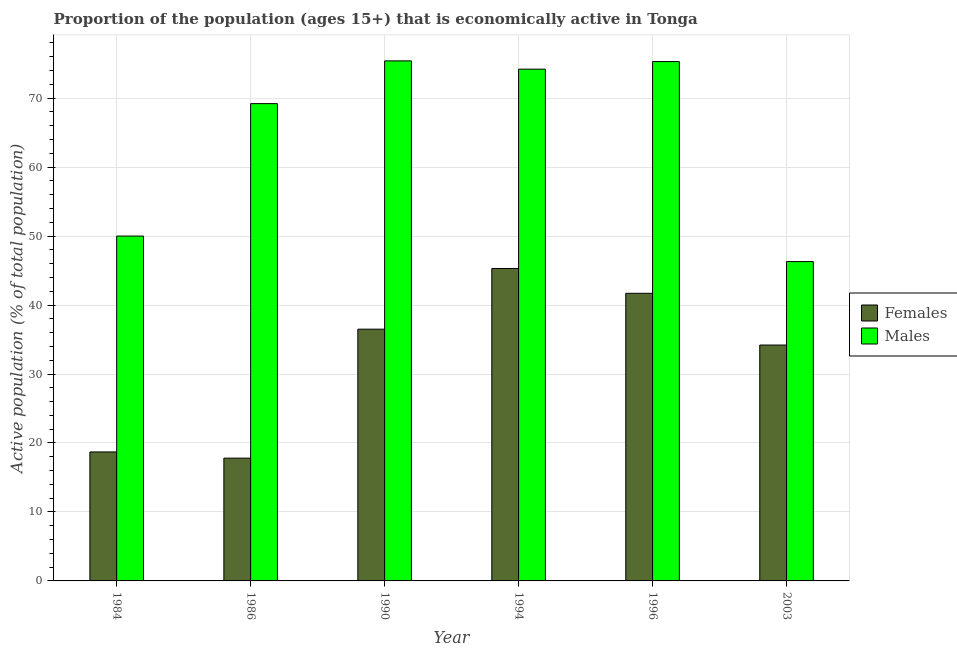How many groups of bars are there?
Ensure brevity in your answer.  6. Are the number of bars per tick equal to the number of legend labels?
Provide a succinct answer. Yes. Are the number of bars on each tick of the X-axis equal?
Your answer should be very brief. Yes. How many bars are there on the 4th tick from the left?
Provide a succinct answer. 2. In how many cases, is the number of bars for a given year not equal to the number of legend labels?
Offer a very short reply. 0. What is the percentage of economically active female population in 1990?
Make the answer very short. 36.5. Across all years, what is the maximum percentage of economically active female population?
Offer a very short reply. 45.3. Across all years, what is the minimum percentage of economically active male population?
Offer a terse response. 46.3. In which year was the percentage of economically active male population maximum?
Give a very brief answer. 1990. What is the total percentage of economically active female population in the graph?
Make the answer very short. 194.2. What is the difference between the percentage of economically active female population in 1990 and that in 1994?
Ensure brevity in your answer.  -8.8. What is the difference between the percentage of economically active male population in 1994 and the percentage of economically active female population in 1990?
Ensure brevity in your answer.  -1.2. What is the average percentage of economically active female population per year?
Your response must be concise. 32.37. In the year 2003, what is the difference between the percentage of economically active male population and percentage of economically active female population?
Provide a short and direct response. 0. In how many years, is the percentage of economically active female population greater than 50 %?
Keep it short and to the point. 0. What is the ratio of the percentage of economically active male population in 1984 to that in 1996?
Your response must be concise. 0.66. Is the percentage of economically active male population in 1990 less than that in 1994?
Make the answer very short. No. What is the difference between the highest and the second highest percentage of economically active male population?
Your answer should be very brief. 0.1. What is the difference between the highest and the lowest percentage of economically active female population?
Give a very brief answer. 27.5. Is the sum of the percentage of economically active male population in 1990 and 2003 greater than the maximum percentage of economically active female population across all years?
Keep it short and to the point. Yes. What does the 1st bar from the left in 1990 represents?
Give a very brief answer. Females. What does the 1st bar from the right in 2003 represents?
Your response must be concise. Males. How many bars are there?
Keep it short and to the point. 12. Are all the bars in the graph horizontal?
Offer a terse response. No. What is the difference between two consecutive major ticks on the Y-axis?
Offer a terse response. 10. Are the values on the major ticks of Y-axis written in scientific E-notation?
Your answer should be compact. No. Does the graph contain any zero values?
Your answer should be compact. No. How are the legend labels stacked?
Provide a succinct answer. Vertical. What is the title of the graph?
Keep it short and to the point. Proportion of the population (ages 15+) that is economically active in Tonga. Does "Methane emissions" appear as one of the legend labels in the graph?
Give a very brief answer. No. What is the label or title of the X-axis?
Give a very brief answer. Year. What is the label or title of the Y-axis?
Your answer should be very brief. Active population (% of total population). What is the Active population (% of total population) of Females in 1984?
Your answer should be very brief. 18.7. What is the Active population (% of total population) of Males in 1984?
Your answer should be very brief. 50. What is the Active population (% of total population) of Females in 1986?
Your response must be concise. 17.8. What is the Active population (% of total population) of Males in 1986?
Provide a short and direct response. 69.2. What is the Active population (% of total population) of Females in 1990?
Your answer should be very brief. 36.5. What is the Active population (% of total population) of Males in 1990?
Provide a short and direct response. 75.4. What is the Active population (% of total population) in Females in 1994?
Provide a short and direct response. 45.3. What is the Active population (% of total population) in Males in 1994?
Offer a very short reply. 74.2. What is the Active population (% of total population) in Females in 1996?
Make the answer very short. 41.7. What is the Active population (% of total population) in Males in 1996?
Offer a very short reply. 75.3. What is the Active population (% of total population) in Females in 2003?
Offer a terse response. 34.2. What is the Active population (% of total population) of Males in 2003?
Your response must be concise. 46.3. Across all years, what is the maximum Active population (% of total population) in Females?
Your answer should be compact. 45.3. Across all years, what is the maximum Active population (% of total population) of Males?
Keep it short and to the point. 75.4. Across all years, what is the minimum Active population (% of total population) of Females?
Your answer should be compact. 17.8. Across all years, what is the minimum Active population (% of total population) in Males?
Provide a succinct answer. 46.3. What is the total Active population (% of total population) of Females in the graph?
Your response must be concise. 194.2. What is the total Active population (% of total population) in Males in the graph?
Give a very brief answer. 390.4. What is the difference between the Active population (% of total population) in Males in 1984 and that in 1986?
Provide a succinct answer. -19.2. What is the difference between the Active population (% of total population) in Females in 1984 and that in 1990?
Your response must be concise. -17.8. What is the difference between the Active population (% of total population) in Males in 1984 and that in 1990?
Provide a succinct answer. -25.4. What is the difference between the Active population (% of total population) of Females in 1984 and that in 1994?
Offer a terse response. -26.6. What is the difference between the Active population (% of total population) in Males in 1984 and that in 1994?
Keep it short and to the point. -24.2. What is the difference between the Active population (% of total population) of Males in 1984 and that in 1996?
Provide a succinct answer. -25.3. What is the difference between the Active population (% of total population) of Females in 1984 and that in 2003?
Make the answer very short. -15.5. What is the difference between the Active population (% of total population) of Males in 1984 and that in 2003?
Give a very brief answer. 3.7. What is the difference between the Active population (% of total population) in Females in 1986 and that in 1990?
Your answer should be very brief. -18.7. What is the difference between the Active population (% of total population) in Females in 1986 and that in 1994?
Your response must be concise. -27.5. What is the difference between the Active population (% of total population) in Males in 1986 and that in 1994?
Your response must be concise. -5. What is the difference between the Active population (% of total population) of Females in 1986 and that in 1996?
Provide a short and direct response. -23.9. What is the difference between the Active population (% of total population) in Females in 1986 and that in 2003?
Keep it short and to the point. -16.4. What is the difference between the Active population (% of total population) in Males in 1986 and that in 2003?
Ensure brevity in your answer.  22.9. What is the difference between the Active population (% of total population) of Males in 1990 and that in 1994?
Make the answer very short. 1.2. What is the difference between the Active population (% of total population) of Females in 1990 and that in 1996?
Ensure brevity in your answer.  -5.2. What is the difference between the Active population (% of total population) of Males in 1990 and that in 2003?
Offer a very short reply. 29.1. What is the difference between the Active population (% of total population) of Males in 1994 and that in 1996?
Your response must be concise. -1.1. What is the difference between the Active population (% of total population) in Females in 1994 and that in 2003?
Offer a terse response. 11.1. What is the difference between the Active population (% of total population) in Males in 1994 and that in 2003?
Provide a succinct answer. 27.9. What is the difference between the Active population (% of total population) of Males in 1996 and that in 2003?
Keep it short and to the point. 29. What is the difference between the Active population (% of total population) of Females in 1984 and the Active population (% of total population) of Males in 1986?
Give a very brief answer. -50.5. What is the difference between the Active population (% of total population) in Females in 1984 and the Active population (% of total population) in Males in 1990?
Give a very brief answer. -56.7. What is the difference between the Active population (% of total population) in Females in 1984 and the Active population (% of total population) in Males in 1994?
Keep it short and to the point. -55.5. What is the difference between the Active population (% of total population) in Females in 1984 and the Active population (% of total population) in Males in 1996?
Provide a short and direct response. -56.6. What is the difference between the Active population (% of total population) of Females in 1984 and the Active population (% of total population) of Males in 2003?
Your answer should be very brief. -27.6. What is the difference between the Active population (% of total population) in Females in 1986 and the Active population (% of total population) in Males in 1990?
Offer a terse response. -57.6. What is the difference between the Active population (% of total population) of Females in 1986 and the Active population (% of total population) of Males in 1994?
Provide a short and direct response. -56.4. What is the difference between the Active population (% of total population) in Females in 1986 and the Active population (% of total population) in Males in 1996?
Offer a very short reply. -57.5. What is the difference between the Active population (% of total population) in Females in 1986 and the Active population (% of total population) in Males in 2003?
Ensure brevity in your answer.  -28.5. What is the difference between the Active population (% of total population) in Females in 1990 and the Active population (% of total population) in Males in 1994?
Your answer should be compact. -37.7. What is the difference between the Active population (% of total population) in Females in 1990 and the Active population (% of total population) in Males in 1996?
Your answer should be compact. -38.8. What is the average Active population (% of total population) of Females per year?
Give a very brief answer. 32.37. What is the average Active population (% of total population) of Males per year?
Your response must be concise. 65.07. In the year 1984, what is the difference between the Active population (% of total population) of Females and Active population (% of total population) of Males?
Ensure brevity in your answer.  -31.3. In the year 1986, what is the difference between the Active population (% of total population) in Females and Active population (% of total population) in Males?
Your answer should be compact. -51.4. In the year 1990, what is the difference between the Active population (% of total population) of Females and Active population (% of total population) of Males?
Make the answer very short. -38.9. In the year 1994, what is the difference between the Active population (% of total population) of Females and Active population (% of total population) of Males?
Give a very brief answer. -28.9. In the year 1996, what is the difference between the Active population (% of total population) of Females and Active population (% of total population) of Males?
Offer a terse response. -33.6. What is the ratio of the Active population (% of total population) of Females in 1984 to that in 1986?
Your answer should be compact. 1.05. What is the ratio of the Active population (% of total population) in Males in 1984 to that in 1986?
Provide a succinct answer. 0.72. What is the ratio of the Active population (% of total population) of Females in 1984 to that in 1990?
Offer a terse response. 0.51. What is the ratio of the Active population (% of total population) of Males in 1984 to that in 1990?
Provide a succinct answer. 0.66. What is the ratio of the Active population (% of total population) of Females in 1984 to that in 1994?
Your answer should be compact. 0.41. What is the ratio of the Active population (% of total population) of Males in 1984 to that in 1994?
Keep it short and to the point. 0.67. What is the ratio of the Active population (% of total population) of Females in 1984 to that in 1996?
Offer a very short reply. 0.45. What is the ratio of the Active population (% of total population) of Males in 1984 to that in 1996?
Offer a terse response. 0.66. What is the ratio of the Active population (% of total population) of Females in 1984 to that in 2003?
Give a very brief answer. 0.55. What is the ratio of the Active population (% of total population) of Males in 1984 to that in 2003?
Your answer should be very brief. 1.08. What is the ratio of the Active population (% of total population) of Females in 1986 to that in 1990?
Your answer should be very brief. 0.49. What is the ratio of the Active population (% of total population) of Males in 1986 to that in 1990?
Your answer should be very brief. 0.92. What is the ratio of the Active population (% of total population) of Females in 1986 to that in 1994?
Keep it short and to the point. 0.39. What is the ratio of the Active population (% of total population) of Males in 1986 to that in 1994?
Give a very brief answer. 0.93. What is the ratio of the Active population (% of total population) of Females in 1986 to that in 1996?
Give a very brief answer. 0.43. What is the ratio of the Active population (% of total population) in Males in 1986 to that in 1996?
Keep it short and to the point. 0.92. What is the ratio of the Active population (% of total population) of Females in 1986 to that in 2003?
Your answer should be compact. 0.52. What is the ratio of the Active population (% of total population) in Males in 1986 to that in 2003?
Make the answer very short. 1.49. What is the ratio of the Active population (% of total population) of Females in 1990 to that in 1994?
Ensure brevity in your answer.  0.81. What is the ratio of the Active population (% of total population) in Males in 1990 to that in 1994?
Your response must be concise. 1.02. What is the ratio of the Active population (% of total population) in Females in 1990 to that in 1996?
Your response must be concise. 0.88. What is the ratio of the Active population (% of total population) in Males in 1990 to that in 1996?
Keep it short and to the point. 1. What is the ratio of the Active population (% of total population) in Females in 1990 to that in 2003?
Your response must be concise. 1.07. What is the ratio of the Active population (% of total population) in Males in 1990 to that in 2003?
Offer a very short reply. 1.63. What is the ratio of the Active population (% of total population) of Females in 1994 to that in 1996?
Make the answer very short. 1.09. What is the ratio of the Active population (% of total population) of Males in 1994 to that in 1996?
Offer a very short reply. 0.99. What is the ratio of the Active population (% of total population) in Females in 1994 to that in 2003?
Provide a succinct answer. 1.32. What is the ratio of the Active population (% of total population) in Males in 1994 to that in 2003?
Give a very brief answer. 1.6. What is the ratio of the Active population (% of total population) of Females in 1996 to that in 2003?
Provide a short and direct response. 1.22. What is the ratio of the Active population (% of total population) of Males in 1996 to that in 2003?
Offer a very short reply. 1.63. What is the difference between the highest and the second highest Active population (% of total population) in Females?
Your answer should be very brief. 3.6. What is the difference between the highest and the lowest Active population (% of total population) in Males?
Your answer should be compact. 29.1. 